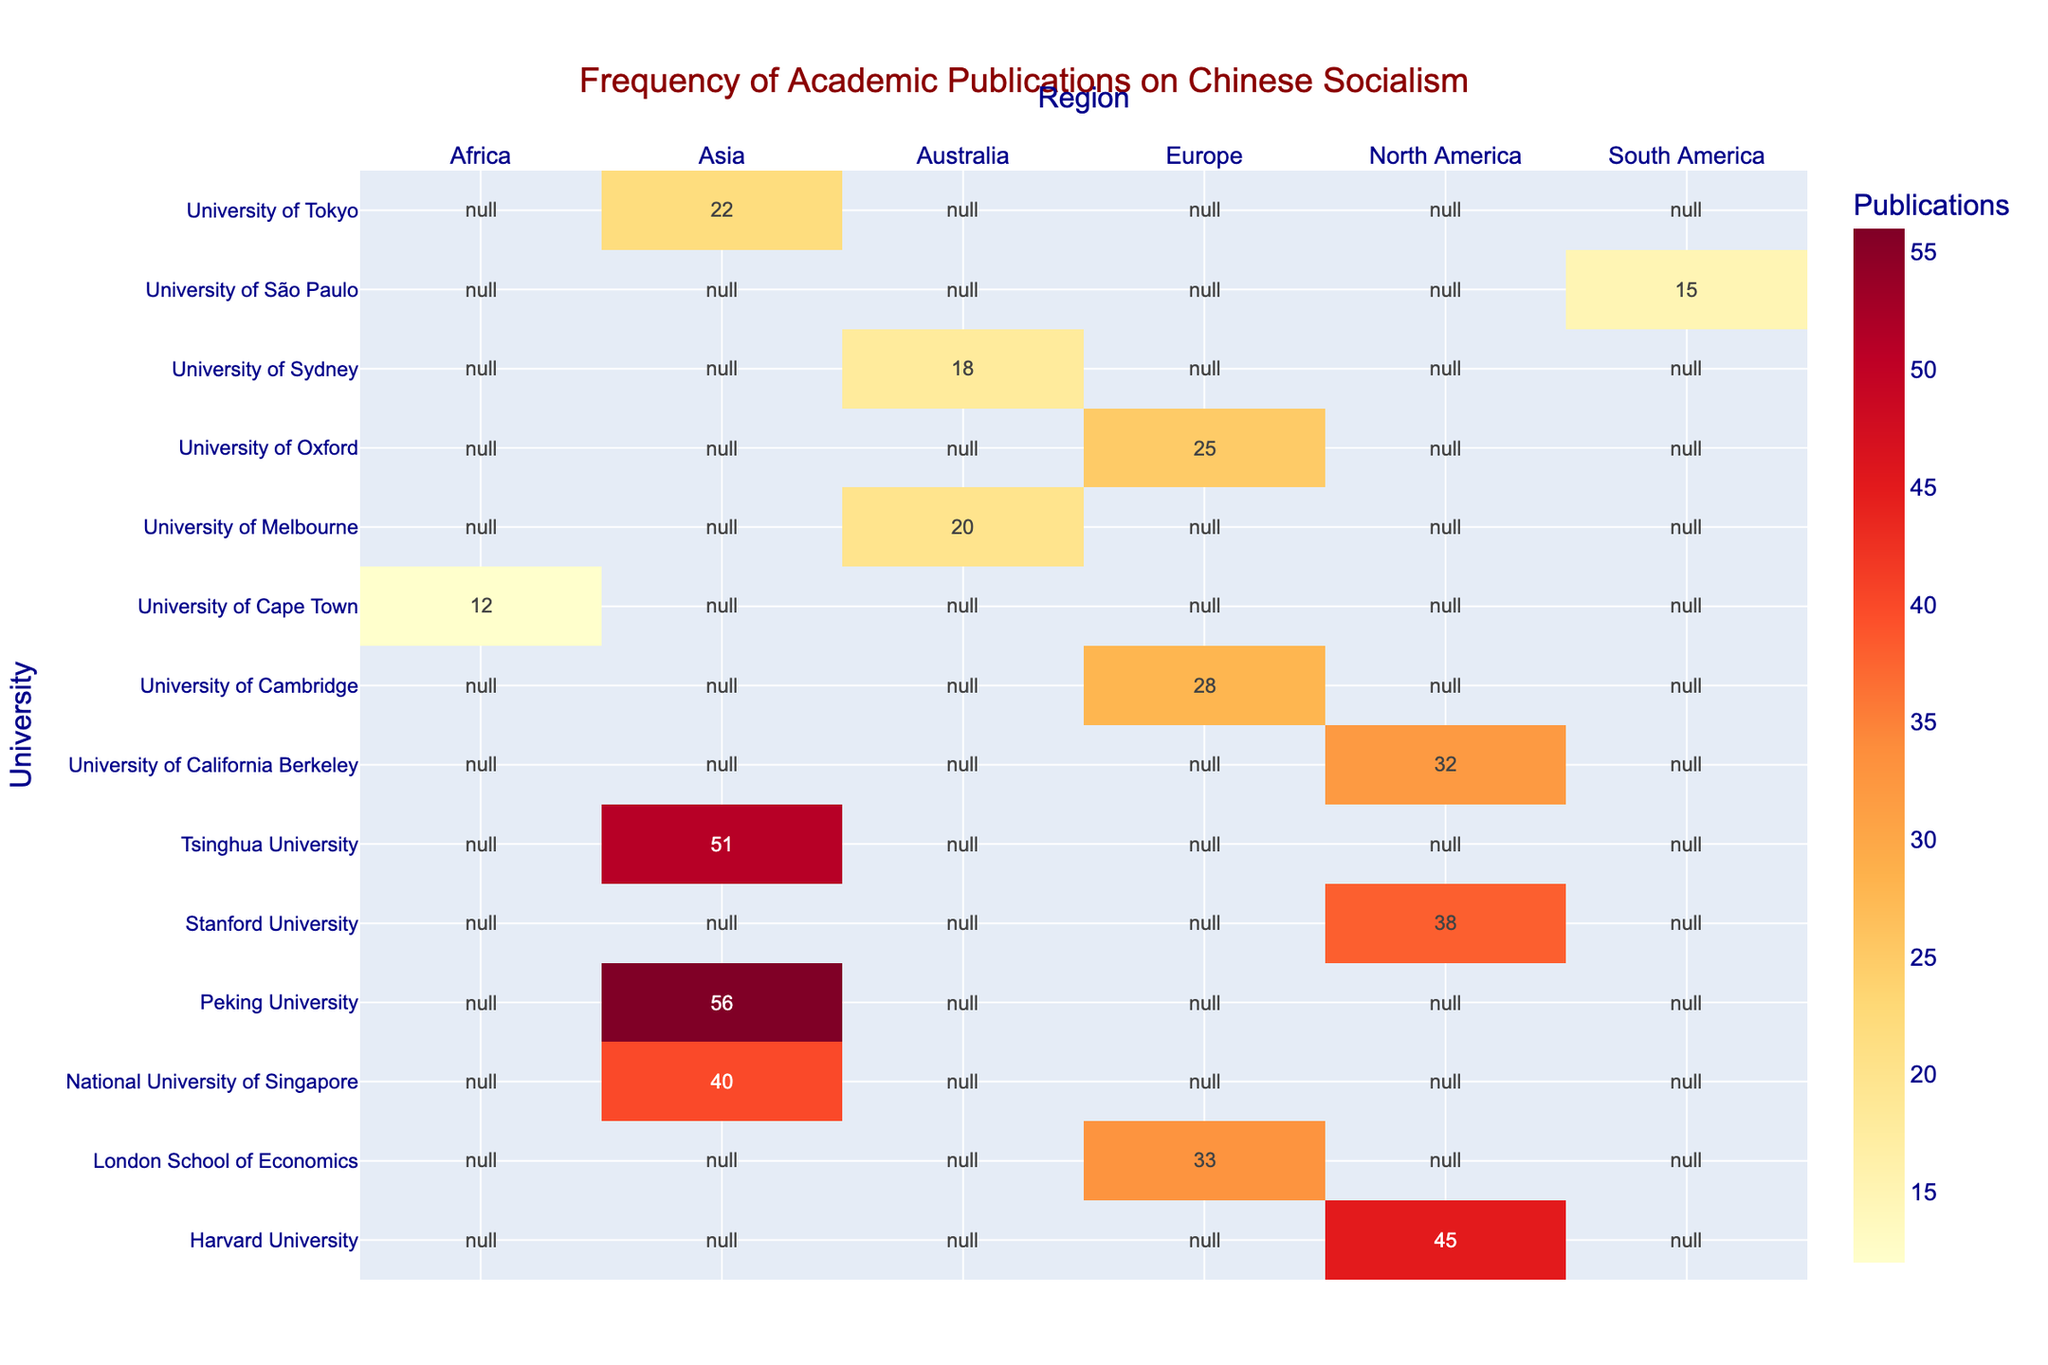What's the title of the heatmap? The title is displayed at the top of the heatmap in a larger font size and reads as: "Frequency of Academic Publications on Chinese Socialism".
Answer: Frequency of Academic Publications on Chinese Socialism Which region has the highest number of universities featured in the heatmap? By counting the number of universities listed for each region, Asia has the most universities featured with four institutions.
Answer: Asia Which university has the highest frequency of publications on Chinese Socialism? On the heatmap, Peking University is shown with the highest frequency value of 56 publications.
Answer: Peking University How many publications does the University of Melbourne have? The heatmap shows the frequency of publications for each university; the University of Melbourne is marked with 20 publications.
Answer: 20 What’s the difference in publication frequency between Tsinghua University and Harvard University? The figure shows Tsinghua University has 51 publications and Harvard University has 45. The difference is calculated as 51 - 45.
Answer: 6 Which universities in North America have a higher frequency of publications than the University of Tokyo? North American universities and their frequencies: Harvard University (45), Stanford University (38), and UC Berkeley (32). Tokyo University has 22. All three North American universities have higher frequencies.
Answer: Harvard University, Stanford University, UC Berkeley What’s the average number of publications for the universities in Europe? The universities in Europe are University of Oxford (25), University of Cambridge (28), and London School of Economics (33). The average is calculated as (25 + 28 + 33)/3.
Answer: 28.67 Which region has the fewest total publications? By adding up the publications for each region: South America (15), Africa (12), Australia (18 + 20 = 38), Asia (56 + 51 + 40 + 22 = 169), Europe (25 + 28 + 33 = 86), North America (45 + 38 + 32 = 115). Africa has the fewest.
Answer: Africa Is the University of Sydney’s publication frequency higher or lower than the University of São Paulo’s? The heatmap shows the University of Sydney with 18 publications and University of São Paulo with 15 publications.
Answer: Higher Which university has the median value of publication frequency among all listed universities? First, list all the frequencies: 12, 15, 18, 20, 22, 25, 28, 32, 33, 38, 40, 45, 51, 56. The median value is the middle value in this ordered list, which is the 7th value.
Answer: University of Cambridge 